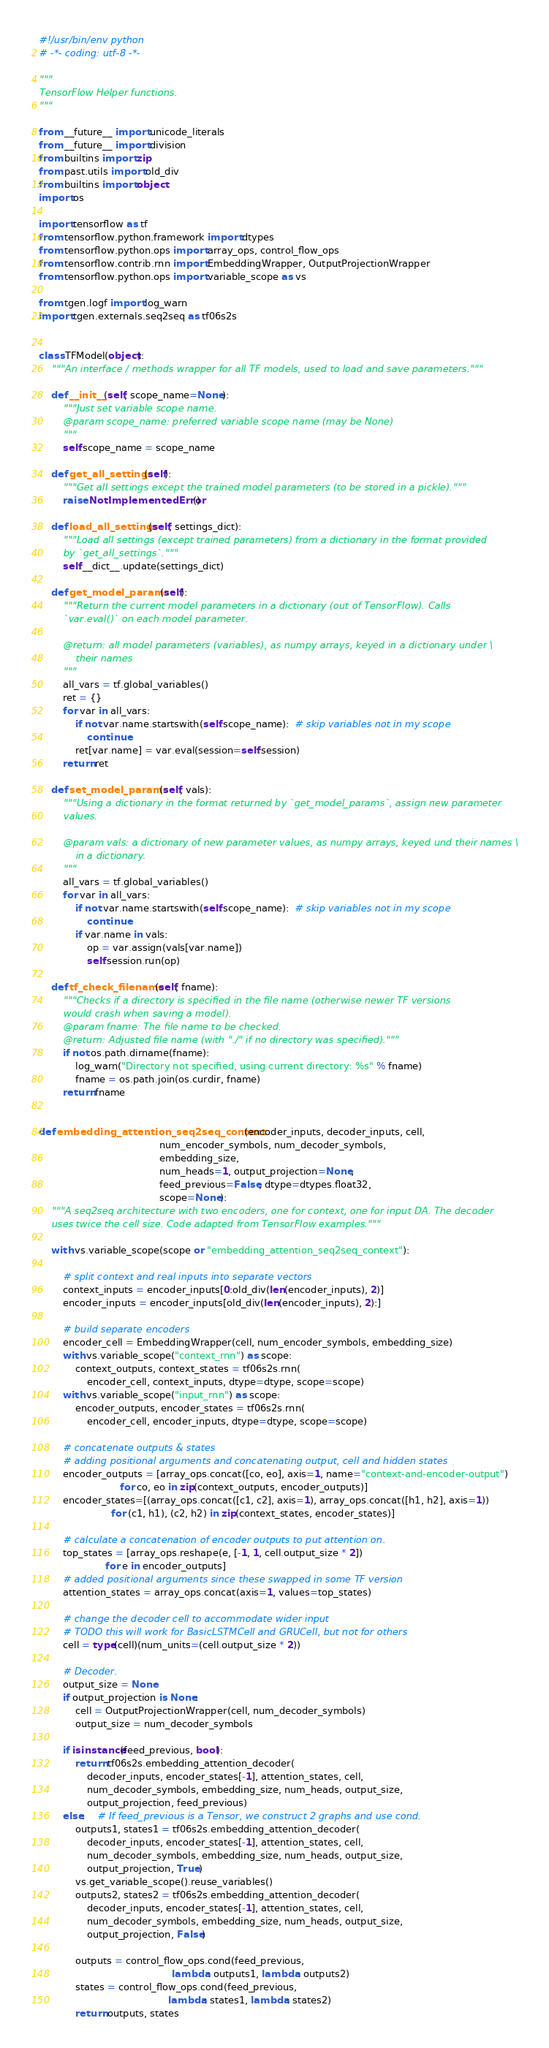Convert code to text. <code><loc_0><loc_0><loc_500><loc_500><_Python_>#!/usr/bin/env python
# -*- coding: utf-8 -*-

"""
TensorFlow Helper functions.
"""

from __future__ import unicode_literals
from __future__ import division
from builtins import zip
from past.utils import old_div
from builtins import object
import os

import tensorflow as tf
from tensorflow.python.framework import dtypes
from tensorflow.python.ops import array_ops, control_flow_ops
from tensorflow.contrib.rnn import EmbeddingWrapper, OutputProjectionWrapper
from tensorflow.python.ops import variable_scope as vs

from tgen.logf import log_warn
import tgen.externals.seq2seq as tf06s2s


class TFModel(object):
    """An interface / methods wrapper for all TF models, used to load and save parameters."""

    def __init__(self, scope_name=None):
        """Just set variable scope name.
        @param scope_name: preferred variable scope name (may be None)
        """
        self.scope_name = scope_name

    def get_all_settings(self):
        """Get all settings except the trained model parameters (to be stored in a pickle)."""
        raise NotImplementedError()

    def load_all_settings(self, settings_dict):
        """Load all settings (except trained parameters) from a dictionary in the format provided
        by `get_all_settings`."""
        self.__dict__.update(settings_dict)

    def get_model_params(self):
        """Return the current model parameters in a dictionary (out of TensorFlow). Calls
        `var.eval()` on each model parameter.

        @return: all model parameters (variables), as numpy arrays, keyed in a dictionary under \
            their names
        """
        all_vars = tf.global_variables()
        ret = {}
        for var in all_vars:
            if not var.name.startswith(self.scope_name):  # skip variables not in my scope
                continue
            ret[var.name] = var.eval(session=self.session)
        return ret

    def set_model_params(self, vals):
        """Using a dictionary in the format returned by `get_model_params`, assign new parameter
        values.

        @param vals: a dictionary of new parameter values, as numpy arrays, keyed und their names \
            in a dictionary.
        """
        all_vars = tf.global_variables()
        for var in all_vars:
            if not var.name.startswith(self.scope_name):  # skip variables not in my scope
                continue
            if var.name in vals:
                op = var.assign(vals[var.name])
                self.session.run(op)

    def tf_check_filename(self, fname):
        """Checks if a directory is specified in the file name (otherwise newer TF versions
        would crash when saving a model).
        @param fname: The file name to be checked.
        @return: Adjusted file name (with "./" if no directory was specified)."""
        if not os.path.dirname(fname):
            log_warn("Directory not specified, using current directory: %s" % fname)
            fname = os.path.join(os.curdir, fname)
        return fname


def embedding_attention_seq2seq_context(encoder_inputs, decoder_inputs, cell,
                                        num_encoder_symbols, num_decoder_symbols,
                                        embedding_size,
                                        num_heads=1, output_projection=None,
                                        feed_previous=False, dtype=dtypes.float32,
                                        scope=None):
    """A seq2seq architecture with two encoders, one for context, one for input DA. The decoder
    uses twice the cell size. Code adapted from TensorFlow examples."""

    with vs.variable_scope(scope or "embedding_attention_seq2seq_context"):

        # split context and real inputs into separate vectors
        context_inputs = encoder_inputs[0:old_div(len(encoder_inputs), 2)]
        encoder_inputs = encoder_inputs[old_div(len(encoder_inputs), 2):]

        # build separate encoders
        encoder_cell = EmbeddingWrapper(cell, num_encoder_symbols, embedding_size)
        with vs.variable_scope("context_rnn") as scope:
            context_outputs, context_states = tf06s2s.rnn(
                encoder_cell, context_inputs, dtype=dtype, scope=scope)
        with vs.variable_scope("input_rnn") as scope:
            encoder_outputs, encoder_states = tf06s2s.rnn(
                encoder_cell, encoder_inputs, dtype=dtype, scope=scope)

        # concatenate outputs & states
        # adding positional arguments and concatenating output, cell and hidden states
        encoder_outputs = [array_ops.concat([co, eo], axis=1, name="context-and-encoder-output")
                           for co, eo in zip(context_outputs, encoder_outputs)]
        encoder_states=[(array_ops.concat([c1, c2], axis=1), array_ops.concat([h1, h2], axis=1))
                        for (c1, h1), (c2, h2) in zip(context_states, encoder_states)]

        # calculate a concatenation of encoder outputs to put attention on.
        top_states = [array_ops.reshape(e, [-1, 1, cell.output_size * 2])
                      for e in encoder_outputs]
        # added positional arguments since these swapped in some TF version
        attention_states = array_ops.concat(axis=1, values=top_states)

        # change the decoder cell to accommodate wider input
        # TODO this will work for BasicLSTMCell and GRUCell, but not for others
        cell = type(cell)(num_units=(cell.output_size * 2))

        # Decoder.
        output_size = None
        if output_projection is None:
            cell = OutputProjectionWrapper(cell, num_decoder_symbols)
            output_size = num_decoder_symbols

        if isinstance(feed_previous, bool):
            return tf06s2s.embedding_attention_decoder(
                decoder_inputs, encoder_states[-1], attention_states, cell,
                num_decoder_symbols, embedding_size, num_heads, output_size,
                output_projection, feed_previous)
        else:    # If feed_previous is a Tensor, we construct 2 graphs and use cond.
            outputs1, states1 = tf06s2s.embedding_attention_decoder(
                decoder_inputs, encoder_states[-1], attention_states, cell,
                num_decoder_symbols, embedding_size, num_heads, output_size,
                output_projection, True)
            vs.get_variable_scope().reuse_variables()
            outputs2, states2 = tf06s2s.embedding_attention_decoder(
                decoder_inputs, encoder_states[-1], attention_states, cell,
                num_decoder_symbols, embedding_size, num_heads, output_size,
                output_projection, False)

            outputs = control_flow_ops.cond(feed_previous,
                                            lambda: outputs1, lambda: outputs2)
            states = control_flow_ops.cond(feed_previous,
                                           lambda: states1, lambda: states2)
            return outputs, states
</code> 